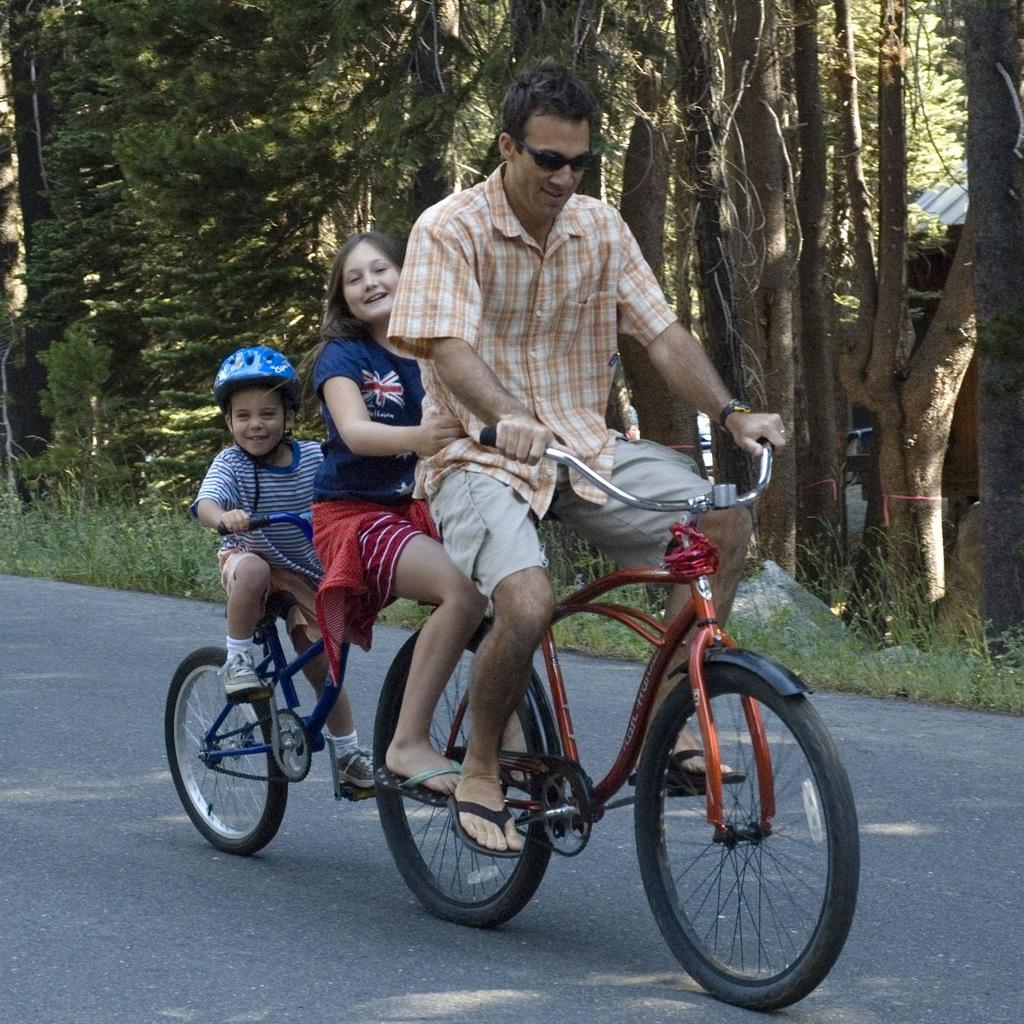How many people are in the image? There are three people in the image. What are the people doing in the image? The people are riding a bicycle. What can be seen in the background of the image? There are trees visible on the side of the image. What is the rate of the doll's movement in the image? There is no doll present in the image, so it is not possible to determine the rate of its movement. 